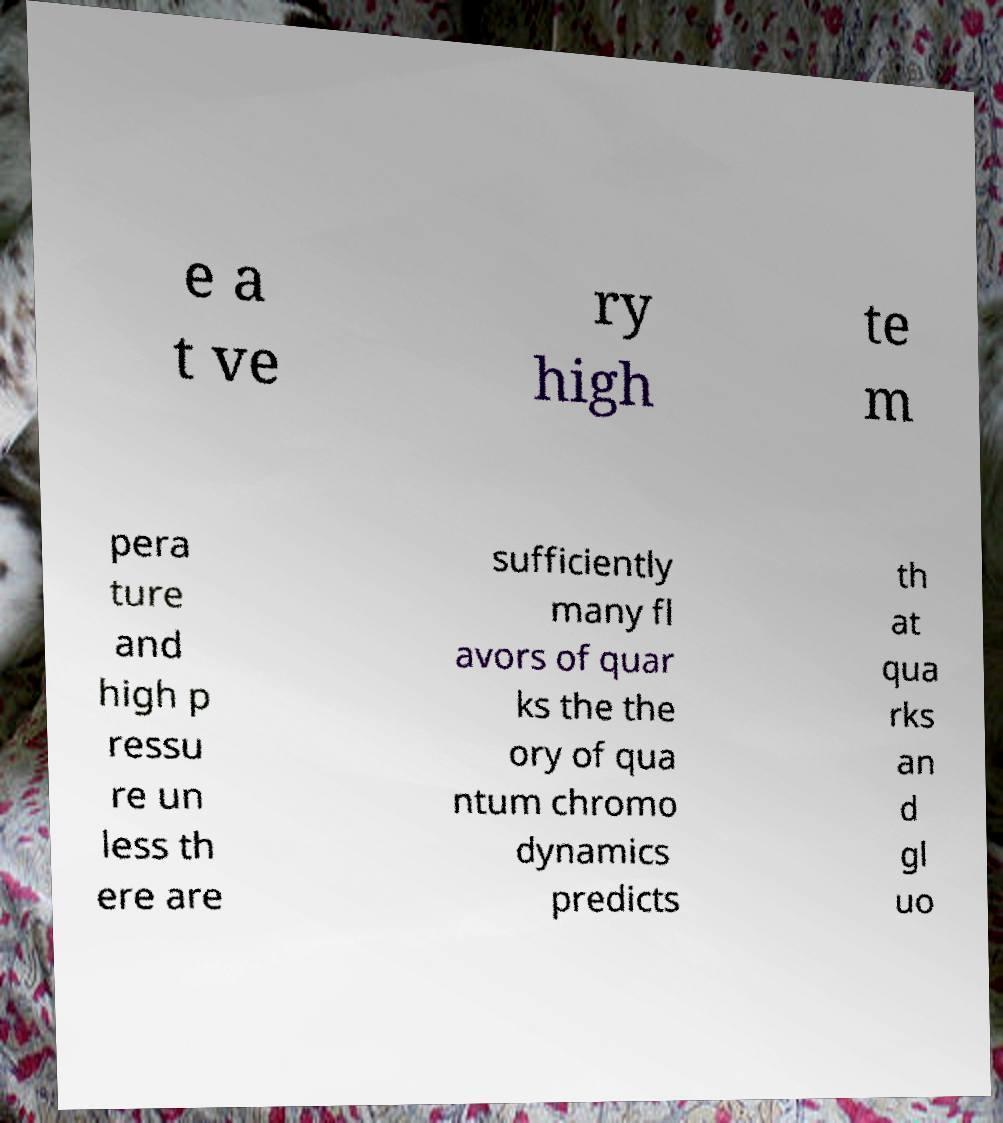Could you extract and type out the text from this image? e a t ve ry high te m pera ture and high p ressu re un less th ere are sufficiently many fl avors of quar ks the the ory of qua ntum chromo dynamics predicts th at qua rks an d gl uo 